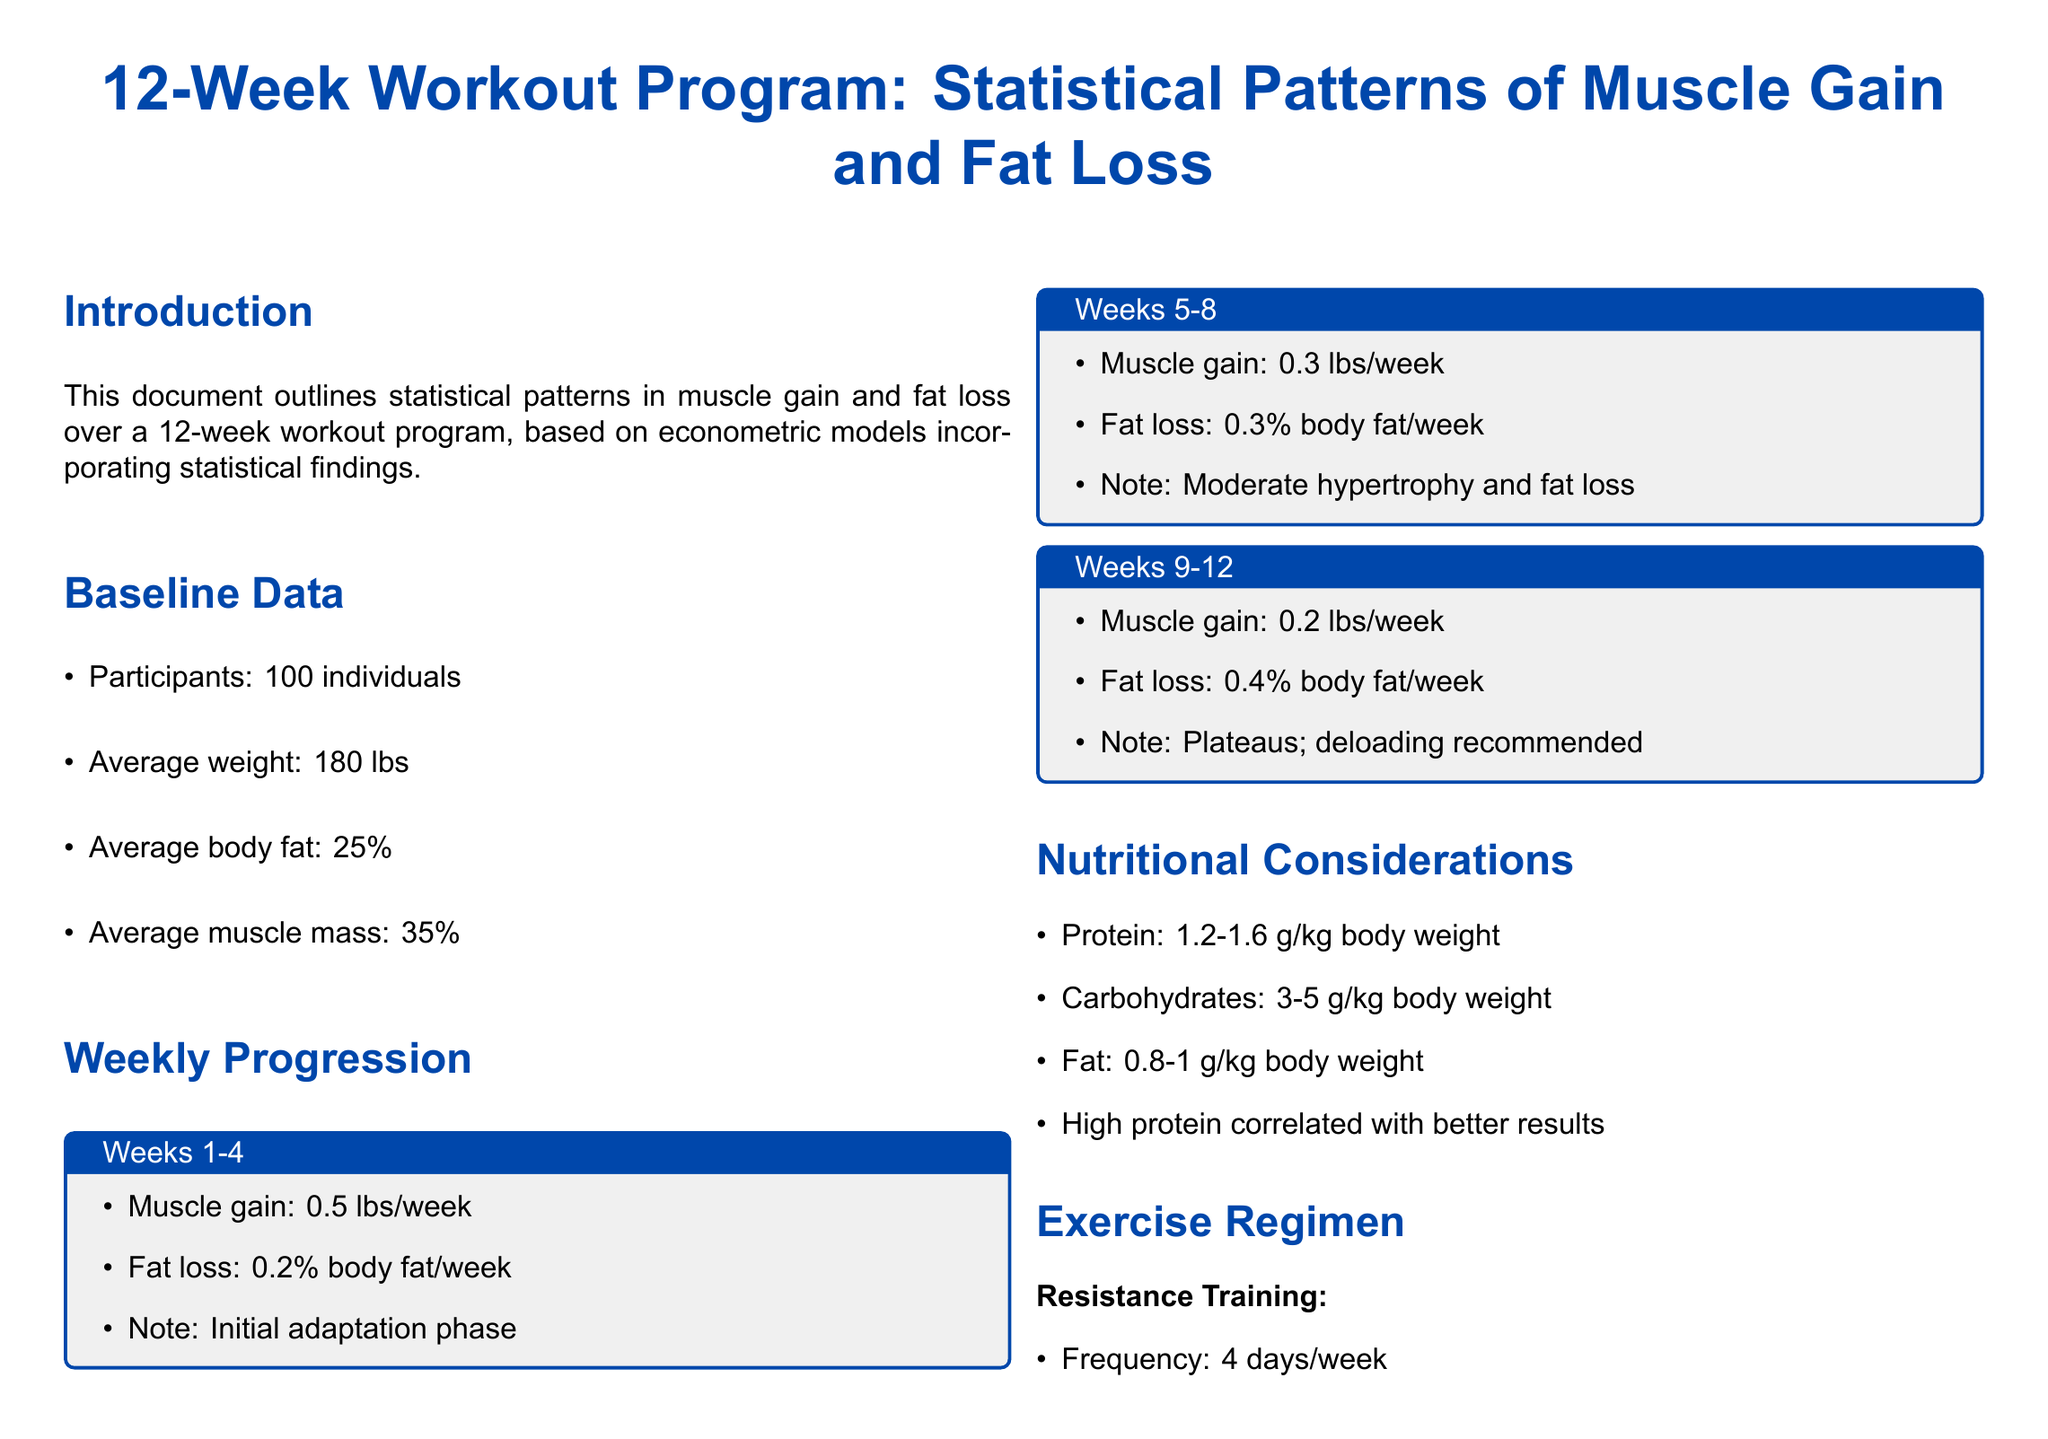What is the average weight of participants? The average weight of participants is stated in the baseline data section of the document.
Answer: 180 lbs What percentage of body fat do participants have on average? The average body fat percentage is provided in the baseline data section of the document.
Answer: 25% How much muscle gain is expected during weeks 1-4? The expected muscle gain for weeks 1-4 is outlined in the weekly progression section of the document.
Answer: 0.5 lbs/week What nutritional recommendation is given for protein intake? The nutritional considerations section specifies the protein intake recommendations based on body weight.
Answer: 1.2-1.6 g/kg body weight What model is recommended for understanding muscle gain and fat loss patterns? The econometric model insights section mentions specific models for analysis.
Answer: ARIMA and GARCH What type of training is performed four days a week? The exercise regimen section outlines specific types of training and their frequency.
Answer: Resistance Training What is the fat loss rate during weeks 5-8? The fat loss rate for weeks 5-8 is detailed in the weekly progression section.
Answer: 0.3% body fat/week What is the duration of cardio sessions according to the document? The exercise regimen specifies the duration for cardio training sessions.
Answer: 20-30 minutes/session What is one notable observation from the time series approach? The econometric model insights section summarizes observations from the time series analysis.
Answer: Decay in muscle gain rate over time 